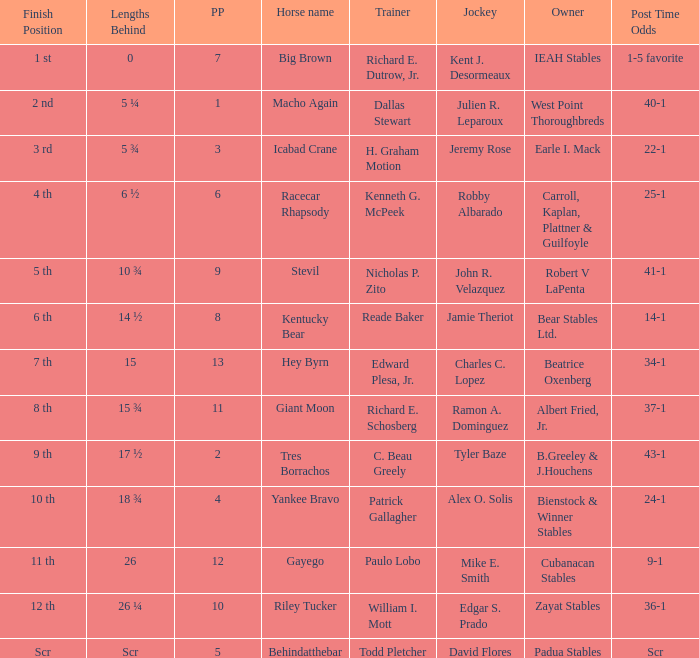What's the post position when the lengths behind is 0? 7.0. 